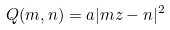Convert formula to latex. <formula><loc_0><loc_0><loc_500><loc_500>Q ( m , n ) = a | m z - n | ^ { 2 }</formula> 